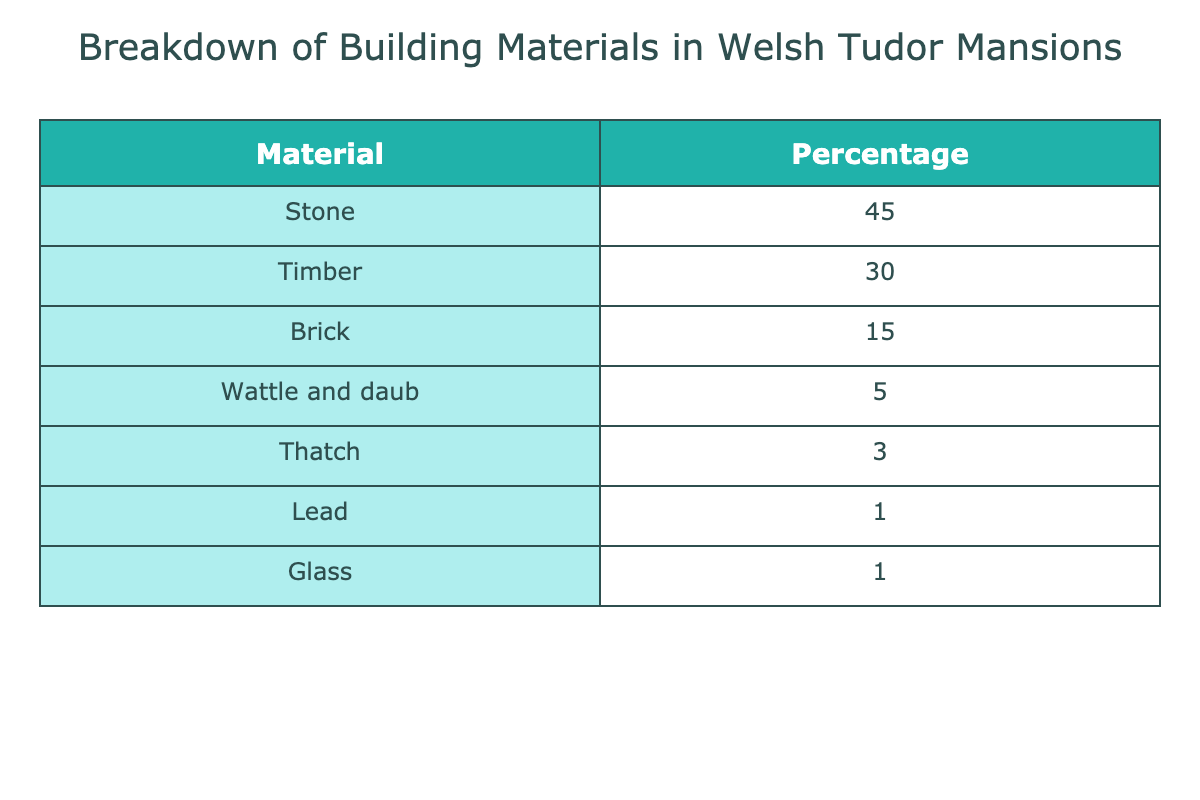What is the most commonly used material in Welsh Tudor mansions? By looking at the table, we can see that stone has the highest percentage at 45%, making it the most commonly used material.
Answer: Stone What percentage of the building materials is made up of timber and brick combined? To find the combined percentage of timber and brick, we add the percentages: Timber (30%) + Brick (15%) = 45%.
Answer: 45% Is thatch used more than wattle and daub? The table shows that thatch is at 3% while wattle and daub is at 5%. Since 3% is less than 5%, thatch is used less than wattle and daub.
Answer: No What percentage of materials are made up of glass and lead combined? Adding glass (1%) and lead (1%) gives us a total of 1% + 1% = 2%.
Answer: 2% If we compare the use of traditional and modern materials, how much is represented by traditional materials (Stone, Timber, Wattle and Daub, Thatch) versus modern materials (Brick, Glass, Lead)? Traditional materials are Stone (45%), Timber (30%), Wattle and Daub (5%), and Thatch (3%), giving a total of 45% + 30% + 5% + 3% = 83%. Modern materials are Brick (15%), Glass (1%), and Lead (1%), adding to 15% + 1% + 1% = 17%. Thus, traditional materials make up 83% while modern materials constitute 17%.
Answer: 83% traditional, 17% modern What is the difference in percentage between the most and least used materials in the table? The most used material is Stone at 45%, and the least used is Lead at 1%. To find the difference, subtract the smallest from the largest: 45% - 1% = 44%.
Answer: 44% 